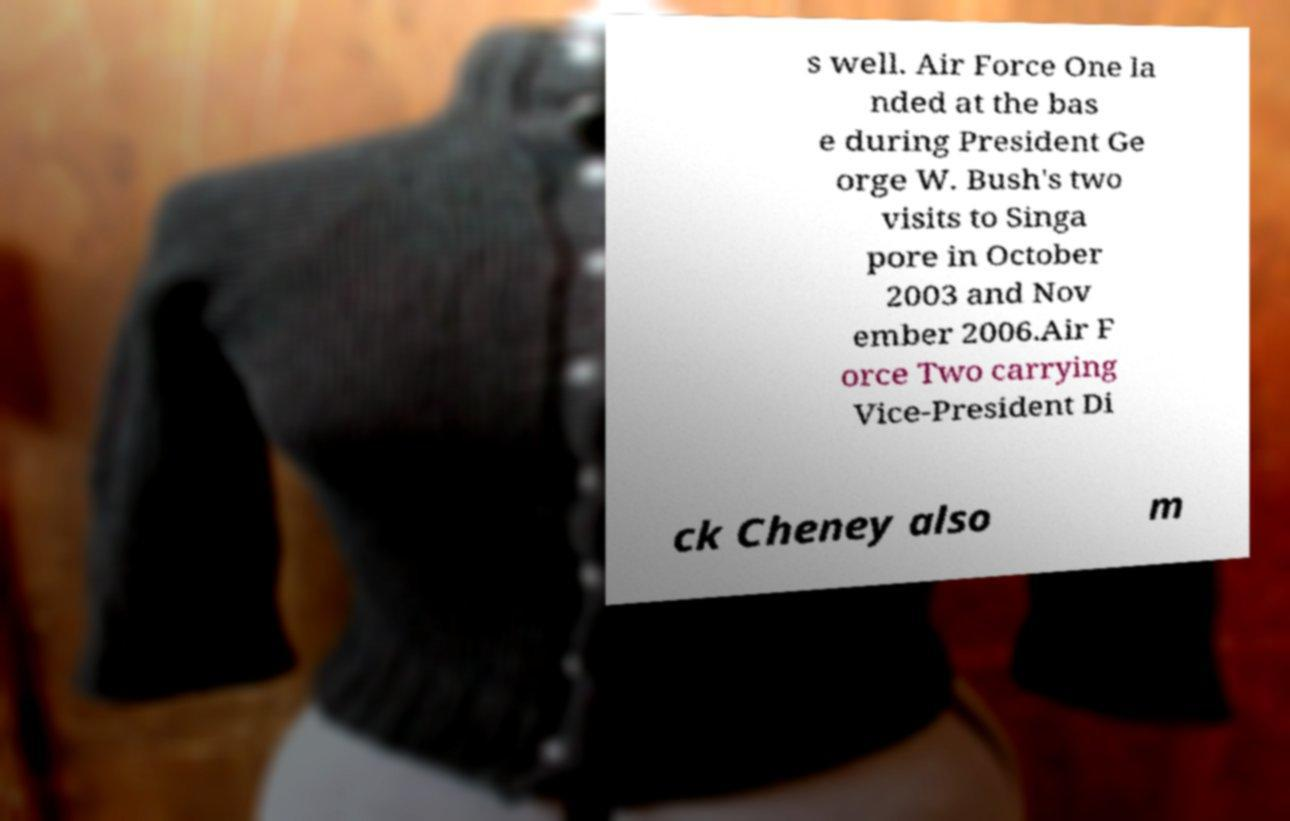For documentation purposes, I need the text within this image transcribed. Could you provide that? s well. Air Force One la nded at the bas e during President Ge orge W. Bush's two visits to Singa pore in October 2003 and Nov ember 2006.Air F orce Two carrying Vice-President Di ck Cheney also m 